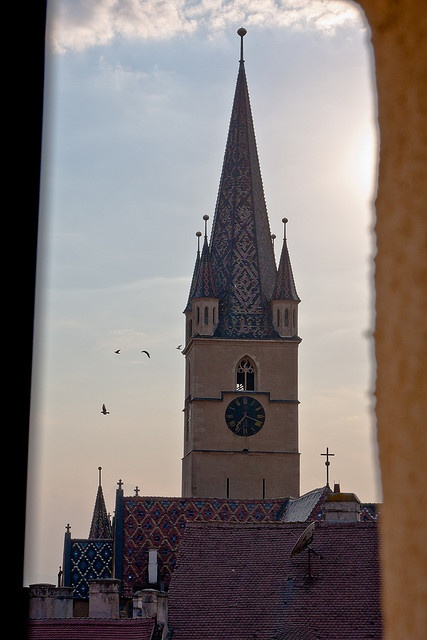Describe the objects in this image and their specific colors. I can see clock in black tones, bird in black and gray tones, bird in black, darkgray, lightgray, and gray tones, bird in black, gray, darkgray, and lightgray tones, and bird in black, gray, and darkgray tones in this image. 